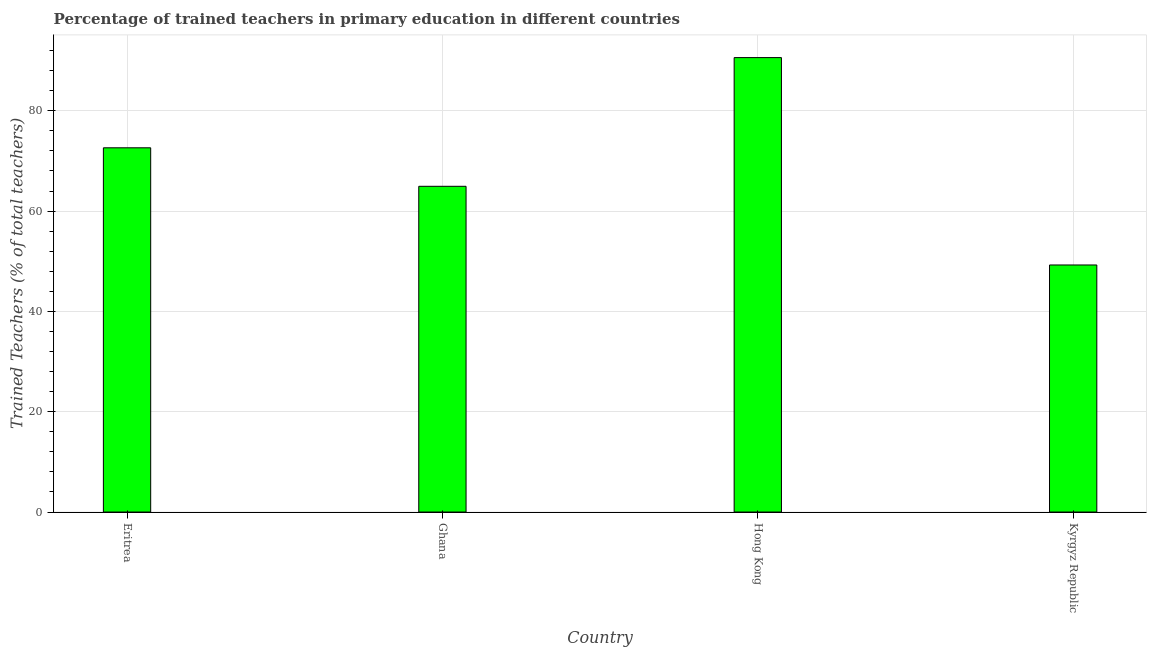Does the graph contain any zero values?
Your response must be concise. No. What is the title of the graph?
Offer a terse response. Percentage of trained teachers in primary education in different countries. What is the label or title of the Y-axis?
Give a very brief answer. Trained Teachers (% of total teachers). What is the percentage of trained teachers in Kyrgyz Republic?
Your answer should be very brief. 49.26. Across all countries, what is the maximum percentage of trained teachers?
Provide a succinct answer. 90.61. Across all countries, what is the minimum percentage of trained teachers?
Your answer should be very brief. 49.26. In which country was the percentage of trained teachers maximum?
Your response must be concise. Hong Kong. In which country was the percentage of trained teachers minimum?
Make the answer very short. Kyrgyz Republic. What is the sum of the percentage of trained teachers?
Provide a short and direct response. 277.43. What is the difference between the percentage of trained teachers in Eritrea and Hong Kong?
Offer a terse response. -17.99. What is the average percentage of trained teachers per country?
Keep it short and to the point. 69.36. What is the median percentage of trained teachers?
Ensure brevity in your answer.  68.78. In how many countries, is the percentage of trained teachers greater than 68 %?
Your answer should be compact. 2. What is the ratio of the percentage of trained teachers in Hong Kong to that in Kyrgyz Republic?
Keep it short and to the point. 1.84. Is the percentage of trained teachers in Ghana less than that in Kyrgyz Republic?
Your answer should be very brief. No. What is the difference between the highest and the second highest percentage of trained teachers?
Provide a succinct answer. 17.99. What is the difference between the highest and the lowest percentage of trained teachers?
Your answer should be very brief. 41.35. In how many countries, is the percentage of trained teachers greater than the average percentage of trained teachers taken over all countries?
Your answer should be very brief. 2. Are the values on the major ticks of Y-axis written in scientific E-notation?
Your response must be concise. No. What is the Trained Teachers (% of total teachers) of Eritrea?
Offer a terse response. 72.62. What is the Trained Teachers (% of total teachers) of Ghana?
Ensure brevity in your answer.  64.94. What is the Trained Teachers (% of total teachers) in Hong Kong?
Offer a terse response. 90.61. What is the Trained Teachers (% of total teachers) in Kyrgyz Republic?
Your answer should be very brief. 49.26. What is the difference between the Trained Teachers (% of total teachers) in Eritrea and Ghana?
Keep it short and to the point. 7.67. What is the difference between the Trained Teachers (% of total teachers) in Eritrea and Hong Kong?
Make the answer very short. -17.99. What is the difference between the Trained Teachers (% of total teachers) in Eritrea and Kyrgyz Republic?
Offer a very short reply. 23.36. What is the difference between the Trained Teachers (% of total teachers) in Ghana and Hong Kong?
Keep it short and to the point. -25.66. What is the difference between the Trained Teachers (% of total teachers) in Ghana and Kyrgyz Republic?
Give a very brief answer. 15.69. What is the difference between the Trained Teachers (% of total teachers) in Hong Kong and Kyrgyz Republic?
Offer a very short reply. 41.35. What is the ratio of the Trained Teachers (% of total teachers) in Eritrea to that in Ghana?
Offer a terse response. 1.12. What is the ratio of the Trained Teachers (% of total teachers) in Eritrea to that in Hong Kong?
Keep it short and to the point. 0.8. What is the ratio of the Trained Teachers (% of total teachers) in Eritrea to that in Kyrgyz Republic?
Your answer should be very brief. 1.47. What is the ratio of the Trained Teachers (% of total teachers) in Ghana to that in Hong Kong?
Your response must be concise. 0.72. What is the ratio of the Trained Teachers (% of total teachers) in Ghana to that in Kyrgyz Republic?
Make the answer very short. 1.32. What is the ratio of the Trained Teachers (% of total teachers) in Hong Kong to that in Kyrgyz Republic?
Offer a very short reply. 1.84. 